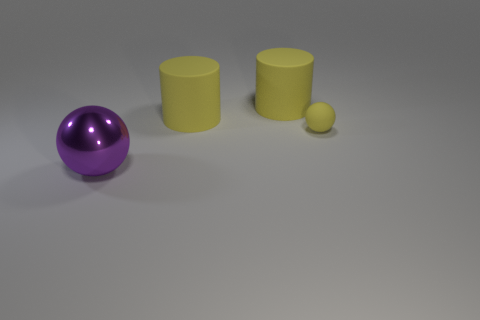How many things are large cylinders or large purple shiny objects?
Your answer should be compact. 3. What number of tiny objects are either yellow cylinders or purple things?
Make the answer very short. 0. How many other objects are the same color as the rubber ball?
Your answer should be very brief. 2. How many big purple metal spheres are left of the object that is in front of the ball on the right side of the purple sphere?
Provide a short and direct response. 0. There is a object in front of the yellow rubber sphere; is it the same size as the small yellow sphere?
Make the answer very short. No. Is the number of purple objects that are behind the purple shiny ball less than the number of large yellow cylinders left of the small matte object?
Offer a very short reply. Yes. Is the number of tiny yellow rubber balls right of the small yellow rubber thing less than the number of balls?
Offer a very short reply. Yes. What number of cylinders are made of the same material as the big purple object?
Your answer should be very brief. 0. There is a sphere to the right of the big metal ball; what material is it?
Offer a terse response. Rubber. Are there any other things of the same color as the metallic thing?
Give a very brief answer. No. 